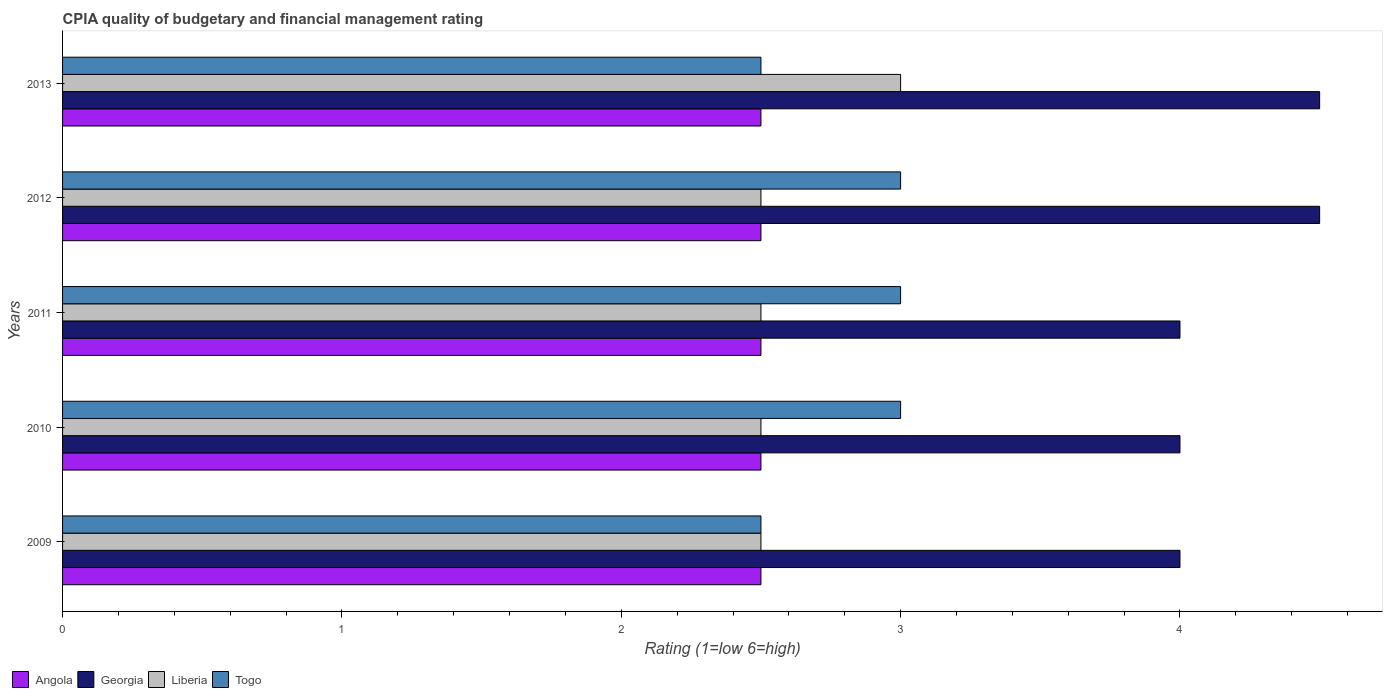How many different coloured bars are there?
Your answer should be compact. 4. Are the number of bars per tick equal to the number of legend labels?
Your response must be concise. Yes. How many bars are there on the 1st tick from the top?
Provide a short and direct response. 4. What is the label of the 5th group of bars from the top?
Your answer should be compact. 2009. In how many cases, is the number of bars for a given year not equal to the number of legend labels?
Provide a short and direct response. 0. What is the CPIA rating in Liberia in 2012?
Provide a short and direct response. 2.5. Across all years, what is the minimum CPIA rating in Togo?
Keep it short and to the point. 2.5. In which year was the CPIA rating in Liberia maximum?
Give a very brief answer. 2013. What is the total CPIA rating in Angola in the graph?
Your response must be concise. 12.5. What is the difference between the CPIA rating in Togo in 2009 and that in 2013?
Give a very brief answer. 0. In the year 2011, what is the difference between the CPIA rating in Georgia and CPIA rating in Togo?
Ensure brevity in your answer.  1. What is the ratio of the CPIA rating in Liberia in 2011 to that in 2013?
Offer a very short reply. 0.83. Is the difference between the CPIA rating in Georgia in 2009 and 2011 greater than the difference between the CPIA rating in Togo in 2009 and 2011?
Give a very brief answer. Yes. What is the difference between the highest and the second highest CPIA rating in Togo?
Your response must be concise. 0. In how many years, is the CPIA rating in Togo greater than the average CPIA rating in Togo taken over all years?
Ensure brevity in your answer.  3. Is the sum of the CPIA rating in Togo in 2009 and 2012 greater than the maximum CPIA rating in Georgia across all years?
Provide a short and direct response. Yes. Is it the case that in every year, the sum of the CPIA rating in Togo and CPIA rating in Liberia is greater than the sum of CPIA rating in Georgia and CPIA rating in Angola?
Your response must be concise. No. What does the 1st bar from the top in 2010 represents?
Your answer should be compact. Togo. What does the 3rd bar from the bottom in 2010 represents?
Make the answer very short. Liberia. Is it the case that in every year, the sum of the CPIA rating in Angola and CPIA rating in Georgia is greater than the CPIA rating in Liberia?
Your response must be concise. Yes. How many bars are there?
Provide a short and direct response. 20. Are all the bars in the graph horizontal?
Your response must be concise. Yes. Does the graph contain grids?
Offer a terse response. No. What is the title of the graph?
Make the answer very short. CPIA quality of budgetary and financial management rating. Does "Israel" appear as one of the legend labels in the graph?
Provide a short and direct response. No. What is the label or title of the X-axis?
Ensure brevity in your answer.  Rating (1=low 6=high). What is the label or title of the Y-axis?
Your response must be concise. Years. What is the Rating (1=low 6=high) of Angola in 2009?
Offer a very short reply. 2.5. What is the Rating (1=low 6=high) of Liberia in 2010?
Provide a succinct answer. 2.5. What is the Rating (1=low 6=high) in Georgia in 2011?
Your answer should be very brief. 4. What is the Rating (1=low 6=high) in Liberia in 2011?
Your answer should be very brief. 2.5. What is the Rating (1=low 6=high) in Togo in 2011?
Your answer should be compact. 3. What is the Rating (1=low 6=high) of Angola in 2012?
Keep it short and to the point. 2.5. What is the Rating (1=low 6=high) of Georgia in 2012?
Give a very brief answer. 4.5. What is the Rating (1=low 6=high) of Liberia in 2012?
Offer a terse response. 2.5. What is the Rating (1=low 6=high) in Angola in 2013?
Ensure brevity in your answer.  2.5. What is the Rating (1=low 6=high) of Georgia in 2013?
Keep it short and to the point. 4.5. Across all years, what is the maximum Rating (1=low 6=high) in Angola?
Your answer should be very brief. 2.5. Across all years, what is the maximum Rating (1=low 6=high) of Georgia?
Ensure brevity in your answer.  4.5. Across all years, what is the maximum Rating (1=low 6=high) in Togo?
Your answer should be compact. 3. Across all years, what is the minimum Rating (1=low 6=high) of Angola?
Ensure brevity in your answer.  2.5. Across all years, what is the minimum Rating (1=low 6=high) of Georgia?
Your answer should be compact. 4. Across all years, what is the minimum Rating (1=low 6=high) of Liberia?
Provide a succinct answer. 2.5. Across all years, what is the minimum Rating (1=low 6=high) in Togo?
Your response must be concise. 2.5. What is the total Rating (1=low 6=high) of Georgia in the graph?
Give a very brief answer. 21. What is the total Rating (1=low 6=high) of Liberia in the graph?
Make the answer very short. 13. What is the difference between the Rating (1=low 6=high) in Angola in 2009 and that in 2010?
Make the answer very short. 0. What is the difference between the Rating (1=low 6=high) of Georgia in 2009 and that in 2010?
Give a very brief answer. 0. What is the difference between the Rating (1=low 6=high) in Georgia in 2009 and that in 2011?
Your answer should be compact. 0. What is the difference between the Rating (1=low 6=high) of Liberia in 2009 and that in 2011?
Provide a short and direct response. 0. What is the difference between the Rating (1=low 6=high) in Togo in 2009 and that in 2011?
Your answer should be very brief. -0.5. What is the difference between the Rating (1=low 6=high) in Georgia in 2009 and that in 2012?
Make the answer very short. -0.5. What is the difference between the Rating (1=low 6=high) in Togo in 2009 and that in 2012?
Provide a succinct answer. -0.5. What is the difference between the Rating (1=low 6=high) in Angola in 2009 and that in 2013?
Give a very brief answer. 0. What is the difference between the Rating (1=low 6=high) in Georgia in 2009 and that in 2013?
Keep it short and to the point. -0.5. What is the difference between the Rating (1=low 6=high) in Liberia in 2009 and that in 2013?
Provide a short and direct response. -0.5. What is the difference between the Rating (1=low 6=high) in Angola in 2010 and that in 2011?
Your response must be concise. 0. What is the difference between the Rating (1=low 6=high) of Georgia in 2010 and that in 2011?
Give a very brief answer. 0. What is the difference between the Rating (1=low 6=high) in Georgia in 2010 and that in 2012?
Offer a terse response. -0.5. What is the difference between the Rating (1=low 6=high) in Liberia in 2010 and that in 2012?
Keep it short and to the point. 0. What is the difference between the Rating (1=low 6=high) in Togo in 2010 and that in 2012?
Keep it short and to the point. 0. What is the difference between the Rating (1=low 6=high) of Angola in 2010 and that in 2013?
Provide a succinct answer. 0. What is the difference between the Rating (1=low 6=high) in Georgia in 2010 and that in 2013?
Keep it short and to the point. -0.5. What is the difference between the Rating (1=low 6=high) of Togo in 2010 and that in 2013?
Provide a succinct answer. 0.5. What is the difference between the Rating (1=low 6=high) in Angola in 2011 and that in 2012?
Ensure brevity in your answer.  0. What is the difference between the Rating (1=low 6=high) in Liberia in 2011 and that in 2012?
Keep it short and to the point. 0. What is the difference between the Rating (1=low 6=high) in Togo in 2011 and that in 2012?
Provide a succinct answer. 0. What is the difference between the Rating (1=low 6=high) of Angola in 2009 and the Rating (1=low 6=high) of Georgia in 2010?
Provide a succinct answer. -1.5. What is the difference between the Rating (1=low 6=high) in Angola in 2009 and the Rating (1=low 6=high) in Togo in 2010?
Provide a short and direct response. -0.5. What is the difference between the Rating (1=low 6=high) in Georgia in 2009 and the Rating (1=low 6=high) in Liberia in 2010?
Keep it short and to the point. 1.5. What is the difference between the Rating (1=low 6=high) in Liberia in 2009 and the Rating (1=low 6=high) in Togo in 2010?
Make the answer very short. -0.5. What is the difference between the Rating (1=low 6=high) of Angola in 2009 and the Rating (1=low 6=high) of Togo in 2011?
Give a very brief answer. -0.5. What is the difference between the Rating (1=low 6=high) of Georgia in 2009 and the Rating (1=low 6=high) of Togo in 2011?
Offer a very short reply. 1. What is the difference between the Rating (1=low 6=high) of Liberia in 2009 and the Rating (1=low 6=high) of Togo in 2011?
Offer a terse response. -0.5. What is the difference between the Rating (1=low 6=high) of Georgia in 2009 and the Rating (1=low 6=high) of Togo in 2012?
Ensure brevity in your answer.  1. What is the difference between the Rating (1=low 6=high) of Angola in 2009 and the Rating (1=low 6=high) of Georgia in 2013?
Your answer should be compact. -2. What is the difference between the Rating (1=low 6=high) in Angola in 2009 and the Rating (1=low 6=high) in Liberia in 2013?
Provide a succinct answer. -0.5. What is the difference between the Rating (1=low 6=high) of Angola in 2009 and the Rating (1=low 6=high) of Togo in 2013?
Offer a terse response. 0. What is the difference between the Rating (1=low 6=high) in Angola in 2010 and the Rating (1=low 6=high) in Georgia in 2011?
Ensure brevity in your answer.  -1.5. What is the difference between the Rating (1=low 6=high) in Angola in 2010 and the Rating (1=low 6=high) in Togo in 2011?
Provide a succinct answer. -0.5. What is the difference between the Rating (1=low 6=high) of Georgia in 2010 and the Rating (1=low 6=high) of Togo in 2011?
Make the answer very short. 1. What is the difference between the Rating (1=low 6=high) in Liberia in 2010 and the Rating (1=low 6=high) in Togo in 2011?
Provide a short and direct response. -0.5. What is the difference between the Rating (1=low 6=high) in Angola in 2010 and the Rating (1=low 6=high) in Georgia in 2012?
Ensure brevity in your answer.  -2. What is the difference between the Rating (1=low 6=high) of Angola in 2010 and the Rating (1=low 6=high) of Liberia in 2012?
Provide a short and direct response. 0. What is the difference between the Rating (1=low 6=high) of Angola in 2010 and the Rating (1=low 6=high) of Togo in 2012?
Your answer should be compact. -0.5. What is the difference between the Rating (1=low 6=high) in Georgia in 2010 and the Rating (1=low 6=high) in Liberia in 2012?
Make the answer very short. 1.5. What is the difference between the Rating (1=low 6=high) in Georgia in 2010 and the Rating (1=low 6=high) in Togo in 2012?
Make the answer very short. 1. What is the difference between the Rating (1=low 6=high) of Georgia in 2010 and the Rating (1=low 6=high) of Liberia in 2013?
Give a very brief answer. 1. What is the difference between the Rating (1=low 6=high) in Liberia in 2010 and the Rating (1=low 6=high) in Togo in 2013?
Your answer should be very brief. 0. What is the difference between the Rating (1=low 6=high) in Angola in 2011 and the Rating (1=low 6=high) in Georgia in 2012?
Your response must be concise. -2. What is the difference between the Rating (1=low 6=high) in Angola in 2011 and the Rating (1=low 6=high) in Liberia in 2012?
Offer a very short reply. 0. What is the difference between the Rating (1=low 6=high) of Liberia in 2011 and the Rating (1=low 6=high) of Togo in 2012?
Provide a succinct answer. -0.5. What is the difference between the Rating (1=low 6=high) in Angola in 2011 and the Rating (1=low 6=high) in Liberia in 2013?
Your response must be concise. -0.5. What is the difference between the Rating (1=low 6=high) of Georgia in 2011 and the Rating (1=low 6=high) of Liberia in 2013?
Your response must be concise. 1. What is the difference between the Rating (1=low 6=high) in Georgia in 2011 and the Rating (1=low 6=high) in Togo in 2013?
Ensure brevity in your answer.  1.5. What is the difference between the Rating (1=low 6=high) of Liberia in 2011 and the Rating (1=low 6=high) of Togo in 2013?
Your answer should be compact. 0. What is the difference between the Rating (1=low 6=high) in Angola in 2012 and the Rating (1=low 6=high) in Georgia in 2013?
Your answer should be compact. -2. What is the difference between the Rating (1=low 6=high) of Angola in 2012 and the Rating (1=low 6=high) of Togo in 2013?
Provide a short and direct response. 0. What is the difference between the Rating (1=low 6=high) in Georgia in 2012 and the Rating (1=low 6=high) in Togo in 2013?
Provide a short and direct response. 2. What is the average Rating (1=low 6=high) of Liberia per year?
Offer a very short reply. 2.6. In the year 2009, what is the difference between the Rating (1=low 6=high) of Georgia and Rating (1=low 6=high) of Togo?
Your answer should be compact. 1.5. In the year 2010, what is the difference between the Rating (1=low 6=high) in Angola and Rating (1=low 6=high) in Liberia?
Offer a very short reply. 0. In the year 2010, what is the difference between the Rating (1=low 6=high) of Angola and Rating (1=low 6=high) of Togo?
Make the answer very short. -0.5. In the year 2010, what is the difference between the Rating (1=low 6=high) of Georgia and Rating (1=low 6=high) of Togo?
Offer a terse response. 1. In the year 2010, what is the difference between the Rating (1=low 6=high) in Liberia and Rating (1=low 6=high) in Togo?
Provide a succinct answer. -0.5. In the year 2011, what is the difference between the Rating (1=low 6=high) in Liberia and Rating (1=low 6=high) in Togo?
Provide a short and direct response. -0.5. In the year 2012, what is the difference between the Rating (1=low 6=high) in Angola and Rating (1=low 6=high) in Liberia?
Your answer should be very brief. 0. In the year 2012, what is the difference between the Rating (1=low 6=high) in Angola and Rating (1=low 6=high) in Togo?
Offer a very short reply. -0.5. In the year 2012, what is the difference between the Rating (1=low 6=high) in Georgia and Rating (1=low 6=high) in Liberia?
Provide a short and direct response. 2. In the year 2012, what is the difference between the Rating (1=low 6=high) in Georgia and Rating (1=low 6=high) in Togo?
Your response must be concise. 1.5. In the year 2012, what is the difference between the Rating (1=low 6=high) in Liberia and Rating (1=low 6=high) in Togo?
Make the answer very short. -0.5. In the year 2013, what is the difference between the Rating (1=low 6=high) of Angola and Rating (1=low 6=high) of Georgia?
Ensure brevity in your answer.  -2. In the year 2013, what is the difference between the Rating (1=low 6=high) of Angola and Rating (1=low 6=high) of Liberia?
Your response must be concise. -0.5. In the year 2013, what is the difference between the Rating (1=low 6=high) of Angola and Rating (1=low 6=high) of Togo?
Keep it short and to the point. 0. In the year 2013, what is the difference between the Rating (1=low 6=high) of Georgia and Rating (1=low 6=high) of Liberia?
Give a very brief answer. 1.5. In the year 2013, what is the difference between the Rating (1=low 6=high) in Georgia and Rating (1=low 6=high) in Togo?
Offer a terse response. 2. In the year 2013, what is the difference between the Rating (1=low 6=high) in Liberia and Rating (1=low 6=high) in Togo?
Your response must be concise. 0.5. What is the ratio of the Rating (1=low 6=high) in Angola in 2009 to that in 2010?
Offer a very short reply. 1. What is the ratio of the Rating (1=low 6=high) in Georgia in 2009 to that in 2010?
Your answer should be very brief. 1. What is the ratio of the Rating (1=low 6=high) in Liberia in 2009 to that in 2010?
Provide a short and direct response. 1. What is the ratio of the Rating (1=low 6=high) in Georgia in 2009 to that in 2011?
Make the answer very short. 1. What is the ratio of the Rating (1=low 6=high) in Togo in 2009 to that in 2011?
Make the answer very short. 0.83. What is the ratio of the Rating (1=low 6=high) in Angola in 2009 to that in 2012?
Your response must be concise. 1. What is the ratio of the Rating (1=low 6=high) of Liberia in 2009 to that in 2012?
Offer a terse response. 1. What is the ratio of the Rating (1=low 6=high) in Angola in 2010 to that in 2011?
Provide a short and direct response. 1. What is the ratio of the Rating (1=low 6=high) of Georgia in 2010 to that in 2011?
Give a very brief answer. 1. What is the ratio of the Rating (1=low 6=high) of Liberia in 2010 to that in 2011?
Your answer should be compact. 1. What is the ratio of the Rating (1=low 6=high) of Liberia in 2010 to that in 2012?
Ensure brevity in your answer.  1. What is the ratio of the Rating (1=low 6=high) of Liberia in 2010 to that in 2013?
Ensure brevity in your answer.  0.83. What is the ratio of the Rating (1=low 6=high) of Georgia in 2011 to that in 2012?
Make the answer very short. 0.89. What is the ratio of the Rating (1=low 6=high) of Togo in 2011 to that in 2012?
Give a very brief answer. 1. What is the ratio of the Rating (1=low 6=high) in Georgia in 2011 to that in 2013?
Give a very brief answer. 0.89. What is the ratio of the Rating (1=low 6=high) of Togo in 2011 to that in 2013?
Provide a succinct answer. 1.2. What is the ratio of the Rating (1=low 6=high) in Liberia in 2012 to that in 2013?
Your answer should be compact. 0.83. What is the ratio of the Rating (1=low 6=high) in Togo in 2012 to that in 2013?
Offer a very short reply. 1.2. What is the difference between the highest and the second highest Rating (1=low 6=high) in Angola?
Offer a terse response. 0. What is the difference between the highest and the second highest Rating (1=low 6=high) in Togo?
Your response must be concise. 0. What is the difference between the highest and the lowest Rating (1=low 6=high) in Liberia?
Ensure brevity in your answer.  0.5. 